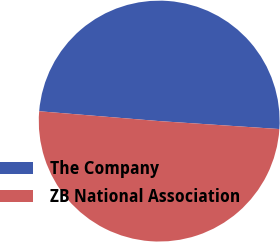Convert chart. <chart><loc_0><loc_0><loc_500><loc_500><pie_chart><fcel>The Company<fcel>ZB National Association<nl><fcel>49.75%<fcel>50.25%<nl></chart> 